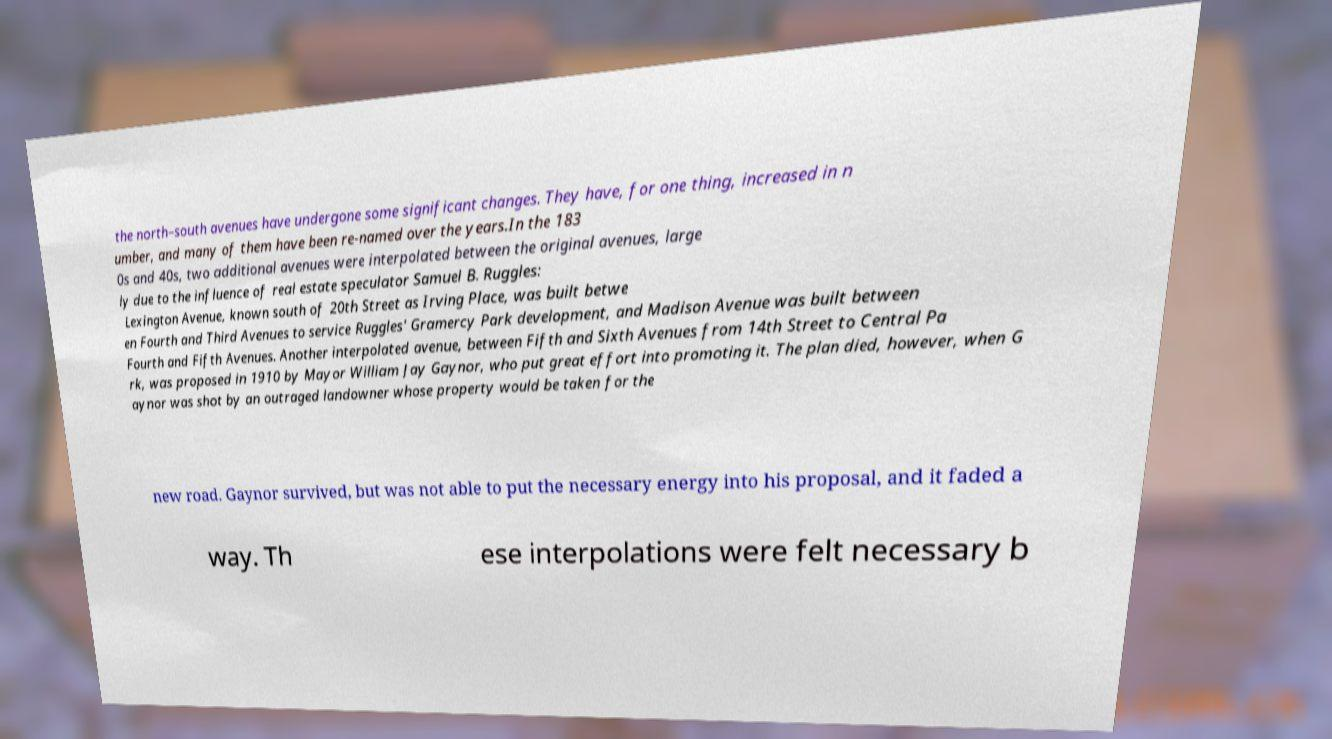Could you assist in decoding the text presented in this image and type it out clearly? the north–south avenues have undergone some significant changes. They have, for one thing, increased in n umber, and many of them have been re-named over the years.In the 183 0s and 40s, two additional avenues were interpolated between the original avenues, large ly due to the influence of real estate speculator Samuel B. Ruggles: Lexington Avenue, known south of 20th Street as Irving Place, was built betwe en Fourth and Third Avenues to service Ruggles' Gramercy Park development, and Madison Avenue was built between Fourth and Fifth Avenues. Another interpolated avenue, between Fifth and Sixth Avenues from 14th Street to Central Pa rk, was proposed in 1910 by Mayor William Jay Gaynor, who put great effort into promoting it. The plan died, however, when G aynor was shot by an outraged landowner whose property would be taken for the new road. Gaynor survived, but was not able to put the necessary energy into his proposal, and it faded a way. Th ese interpolations were felt necessary b 